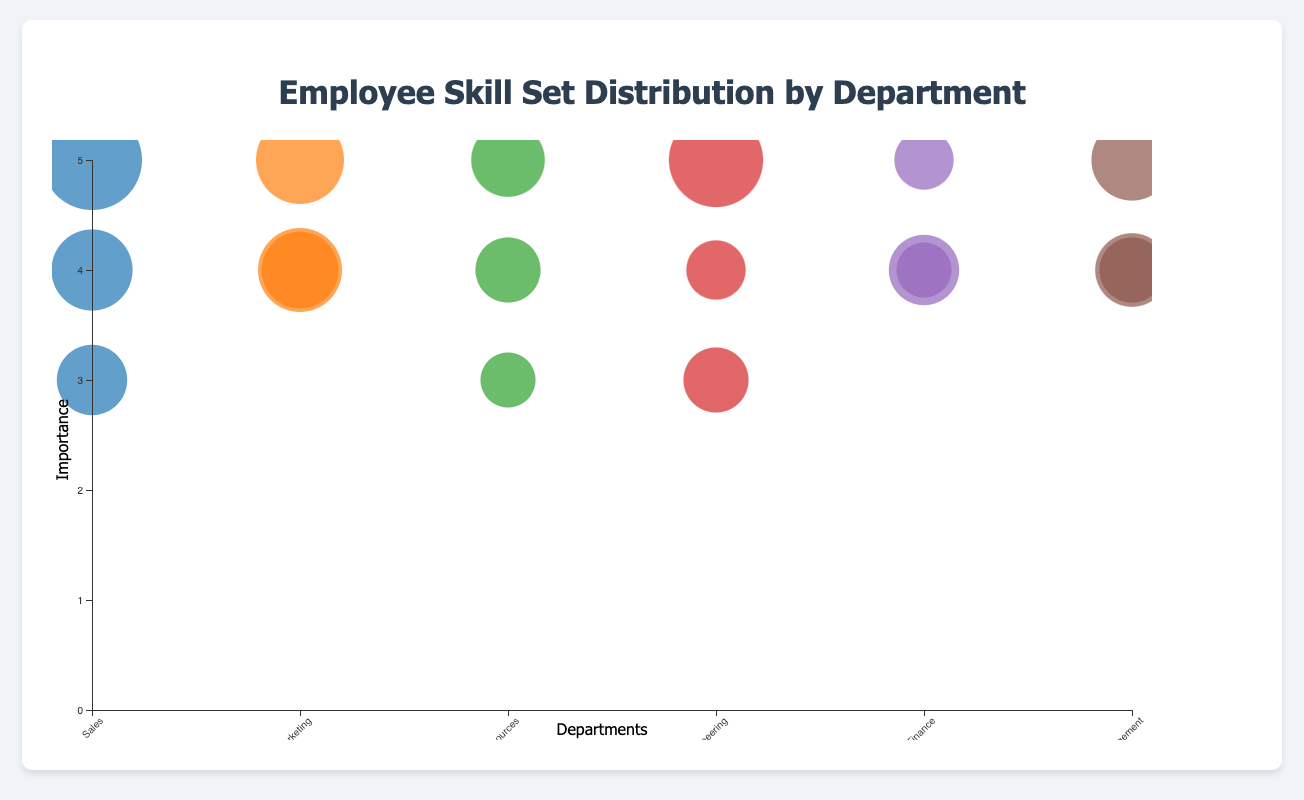What is the title of the chart? The title is displayed at the top center of the figure.
Answer: Employee Skill Set Distribution by Department Which skill has the largest count in the Sales department? By looking at the size of the bubbles categorized under the Sales department, the largest count bubble corresponds to Customer Relations.
Answer: Customer Relations How many skills have a count of 20 in the entire chart? Scan the entire chart to locate and count all bubbles labeled with a count of 20.
Answer: 2 Which department has the highest average skill importance? Calculate the average importance for each department by summing the importance values for each skill and dividing by the number of skills in that department. Sales: (4+5+3)/3 = 4, Marketing: (5+4+4)/3 = 4.33, Human Resources: (5+4+3)/3 = 4, Engineering: (5+4+3)/3 = 4, Finance: (4+5+4)/3 = 4.33, Operational Management: (4+4+5)/3 = 4.33. The Marketing, Finance, and Operational Management departments have the highest average skill importance of 4.33.
Answer: Marketing, Finance, Operational Management Compare the number of counts between Software Development and Market Analysis. Find and compare the sizes of the bubbles for Software Development in Engineering and Market Analysis in Sales. Software Development has 35 counts, and Market Analysis has 18 counts.
Answer: Software Development has higher counts Which department has a skill bubble positioned highest on the y-axis? The highest bubble on the y-axis corresponds to a skill with an importance of 5. Identify which department contains this skill. Multiple departments might have, so outline them all.
Answer: Multiple departments: Sales (Customer Relations), Marketing (SEO), Human Resources (Recruitment), Engineering (Software Development), and Operational Management (Project Management) What is the total number of skills displayed across all departments? Sum up all individual skills in the chart. Sales: 3, Marketing: 3, Human Resources: 3, Engineering: 3, Finance: 3, Operational Management: 3, resulting in 3 * 6 = 18 skills in total.
Answer: 18 Which skill in Finance has the highest importance and what is its count? Identify the skill bubble in Finance with the highest y-axis value; in this case, Accounting has an importance of 5. Then, check its count.
Answer: Accounting, 12 Which department is associated with the color representing the Social Media skill? Identify the color of the bubble for Social Media, and then match it with the department's color code visible in the legend.
Answer: Marketing If you combine the counts of Project Management and Process Optimization in Operational Management, what is the total? Sum up the counts for Project Management (25) and Process Optimization (20) in the Operational Management department. The total is 25 + 20 = 45.
Answer: 45 